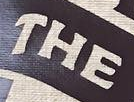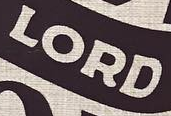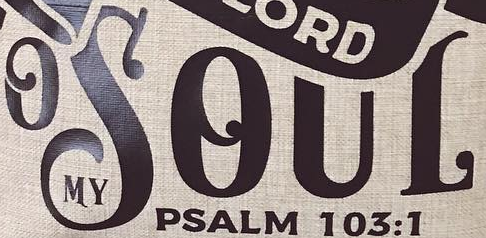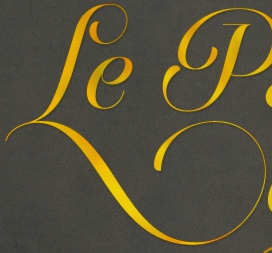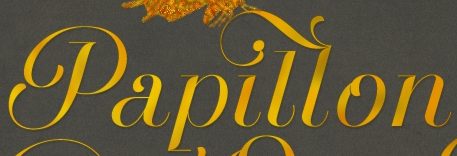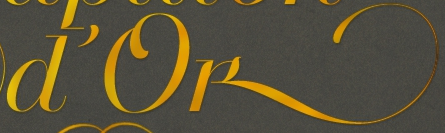Transcribe the words shown in these images in order, separated by a semicolon. THE; LORD; OSOUL; Le; Papillon; D'ok 